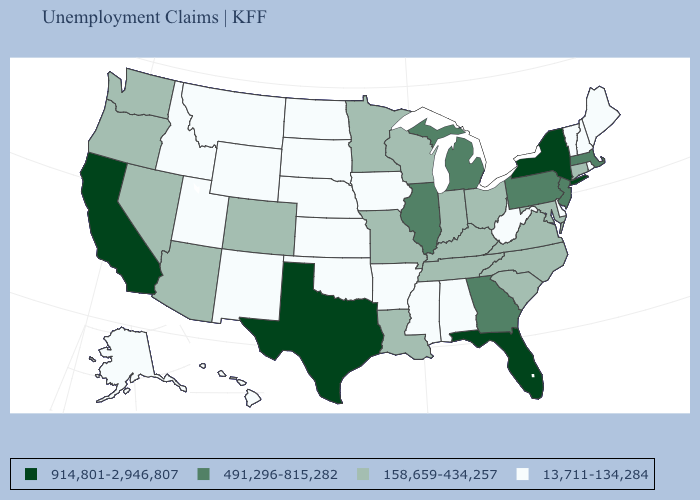Does the map have missing data?
Give a very brief answer. No. What is the value of Florida?
Answer briefly. 914,801-2,946,807. Which states have the highest value in the USA?
Keep it brief. California, Florida, New York, Texas. What is the value of Arizona?
Be succinct. 158,659-434,257. Name the states that have a value in the range 914,801-2,946,807?
Write a very short answer. California, Florida, New York, Texas. Name the states that have a value in the range 914,801-2,946,807?
Be succinct. California, Florida, New York, Texas. What is the value of Illinois?
Keep it brief. 491,296-815,282. Does Kansas have the same value as Iowa?
Be succinct. Yes. What is the value of Iowa?
Give a very brief answer. 13,711-134,284. Name the states that have a value in the range 158,659-434,257?
Concise answer only. Arizona, Colorado, Connecticut, Indiana, Kentucky, Louisiana, Maryland, Minnesota, Missouri, Nevada, North Carolina, Ohio, Oregon, South Carolina, Tennessee, Virginia, Washington, Wisconsin. Among the states that border Idaho , which have the lowest value?
Keep it brief. Montana, Utah, Wyoming. What is the value of Vermont?
Concise answer only. 13,711-134,284. Which states have the lowest value in the MidWest?
Write a very short answer. Iowa, Kansas, Nebraska, North Dakota, South Dakota. Does Indiana have a higher value than Kansas?
Give a very brief answer. Yes. Name the states that have a value in the range 914,801-2,946,807?
Keep it brief. California, Florida, New York, Texas. 